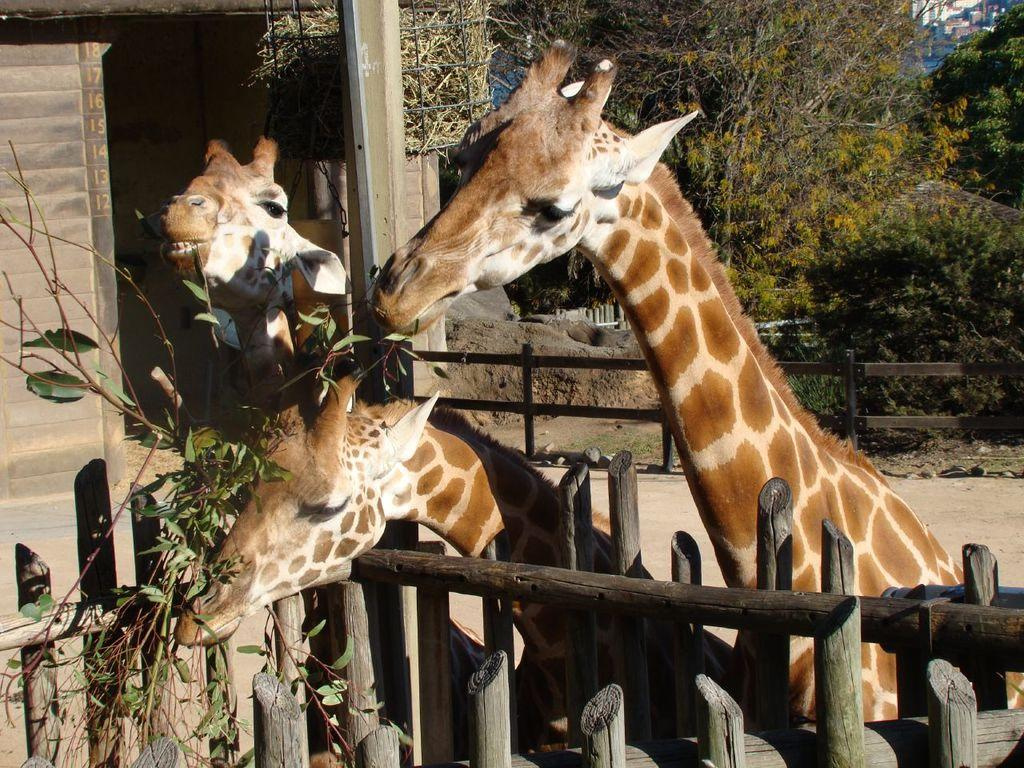How many giraffes are in the image? There are 3 giraffes in the image. What are the giraffes doing in the image? The giraffes are eating the leaves of a plant. What can be seen on the right side of the image? There are trees on the right side of the image. How many beds are visible in the image? There are no beds present in the image; it features 3 giraffes eating leaves from a plant. Can you tell me how many ants are crawling on the giraffes in the image? There are no ants visible in the image; it only shows the giraffes eating leaves from a plant. 